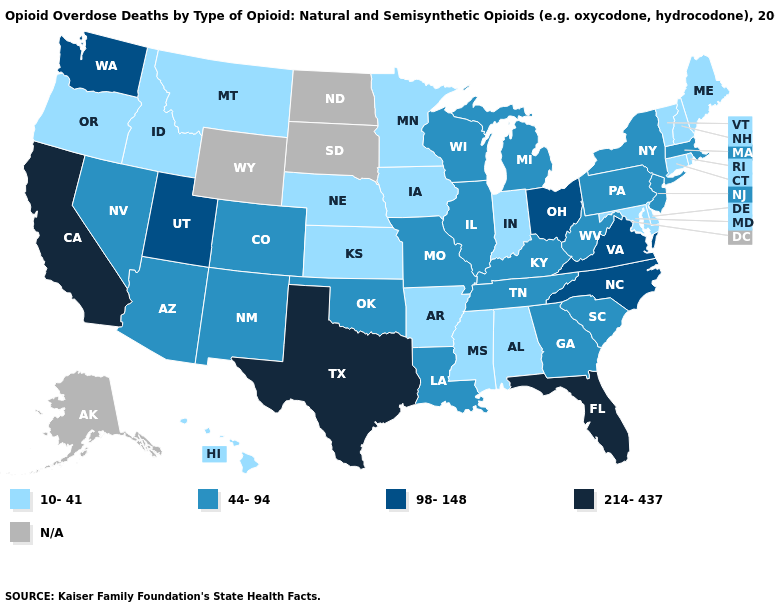What is the value of Maine?
Short answer required. 10-41. What is the highest value in the Northeast ?
Quick response, please. 44-94. Which states hav the highest value in the South?
Be succinct. Florida, Texas. What is the highest value in the South ?
Answer briefly. 214-437. What is the value of Oregon?
Be succinct. 10-41. What is the lowest value in the USA?
Answer briefly. 10-41. What is the value of Colorado?
Give a very brief answer. 44-94. How many symbols are there in the legend?
Give a very brief answer. 5. Among the states that border Utah , does Nevada have the highest value?
Be succinct. Yes. What is the highest value in the USA?
Quick response, please. 214-437. Name the states that have a value in the range 98-148?
Answer briefly. North Carolina, Ohio, Utah, Virginia, Washington. Among the states that border Pennsylvania , which have the lowest value?
Be succinct. Delaware, Maryland. Which states have the highest value in the USA?
Quick response, please. California, Florida, Texas. Name the states that have a value in the range 44-94?
Answer briefly. Arizona, Colorado, Georgia, Illinois, Kentucky, Louisiana, Massachusetts, Michigan, Missouri, Nevada, New Jersey, New Mexico, New York, Oklahoma, Pennsylvania, South Carolina, Tennessee, West Virginia, Wisconsin. 